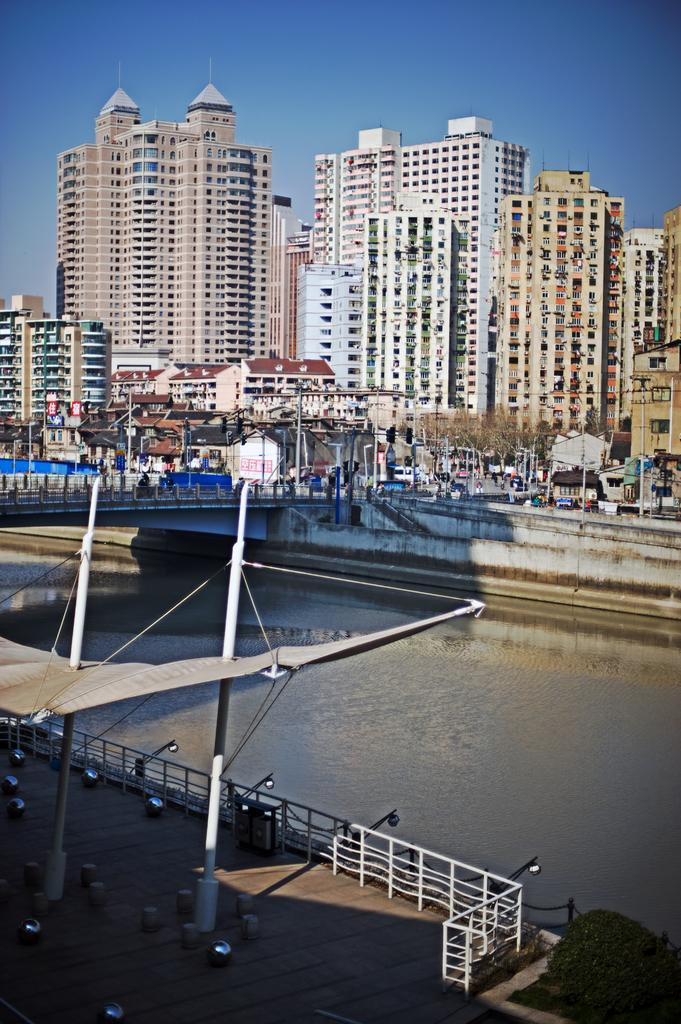What structures are present in the image? There are poles and a fence in the image. What can be seen attached to the poles? There are lights attached to the poles in the image. What is visible in the background of the image? There are buildings and trees in the background of the image. Is there any water visible in the image? Yes, there is water visible in the image. What type of animals can be seen at the zoo in the image? There is no zoo present in the image; it features poles, lights, a fence, water, buildings, and trees. 